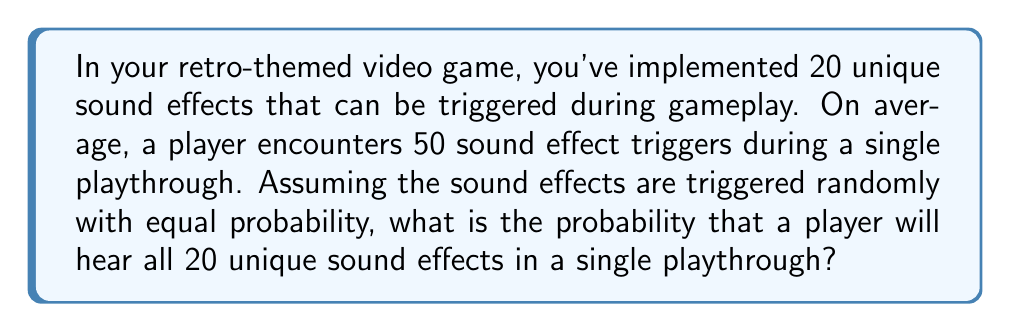Provide a solution to this math problem. To solve this problem, we can use the concept of the "Coupon Collector's Problem" in probability theory. Here's the step-by-step solution:

1) First, we need to calculate the probability of not hearing all 20 sound effects. This is easier than calculating the probability of hearing all of them.

2) The probability of not hearing all sound effects is equivalent to the probability of missing at least one sound effect out of the 20.

3) For each sound effect trigger, the probability of not hearing a specific sound effect is $\frac{19}{20}$.

4) The probability of not hearing a specific sound effect in 50 triggers is $(\frac{19}{20})^{50}$.

5) The probability of hearing a specific sound effect at least once in 50 triggers is $1 - (\frac{19}{20})^{50}$.

6) Now, we need the probability of hearing all 20 sound effects. This is equivalent to hearing each of the 20 sound effects at least once.

7) The probability of this happening is:

   $$P(\text{all 20 heard}) = (1 - (\frac{19}{20})^{50})^{20}$$

8) Let's calculate this:
   
   $$P(\text{all 20 heard}) = (1 - (0.95)^{50})^{20}$$
   $$= (1 - 0.0769)^{20}$$
   $$= (0.9231)^{20}$$
   $$\approx 0.1977$$

9) Convert to a percentage: 0.1977 * 100 ≈ 19.77%
Answer: The probability that a player will hear all 20 unique sound effects in a single playthrough is approximately 19.77% or about 0.1977. 